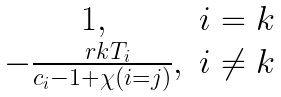Convert formula to latex. <formula><loc_0><loc_0><loc_500><loc_500>\begin{matrix} 1 , & i = k \\ - \frac { \ r k T _ { i } } { c _ { i } - 1 + \chi ( i = j ) } , & i \ne k \end{matrix}</formula> 